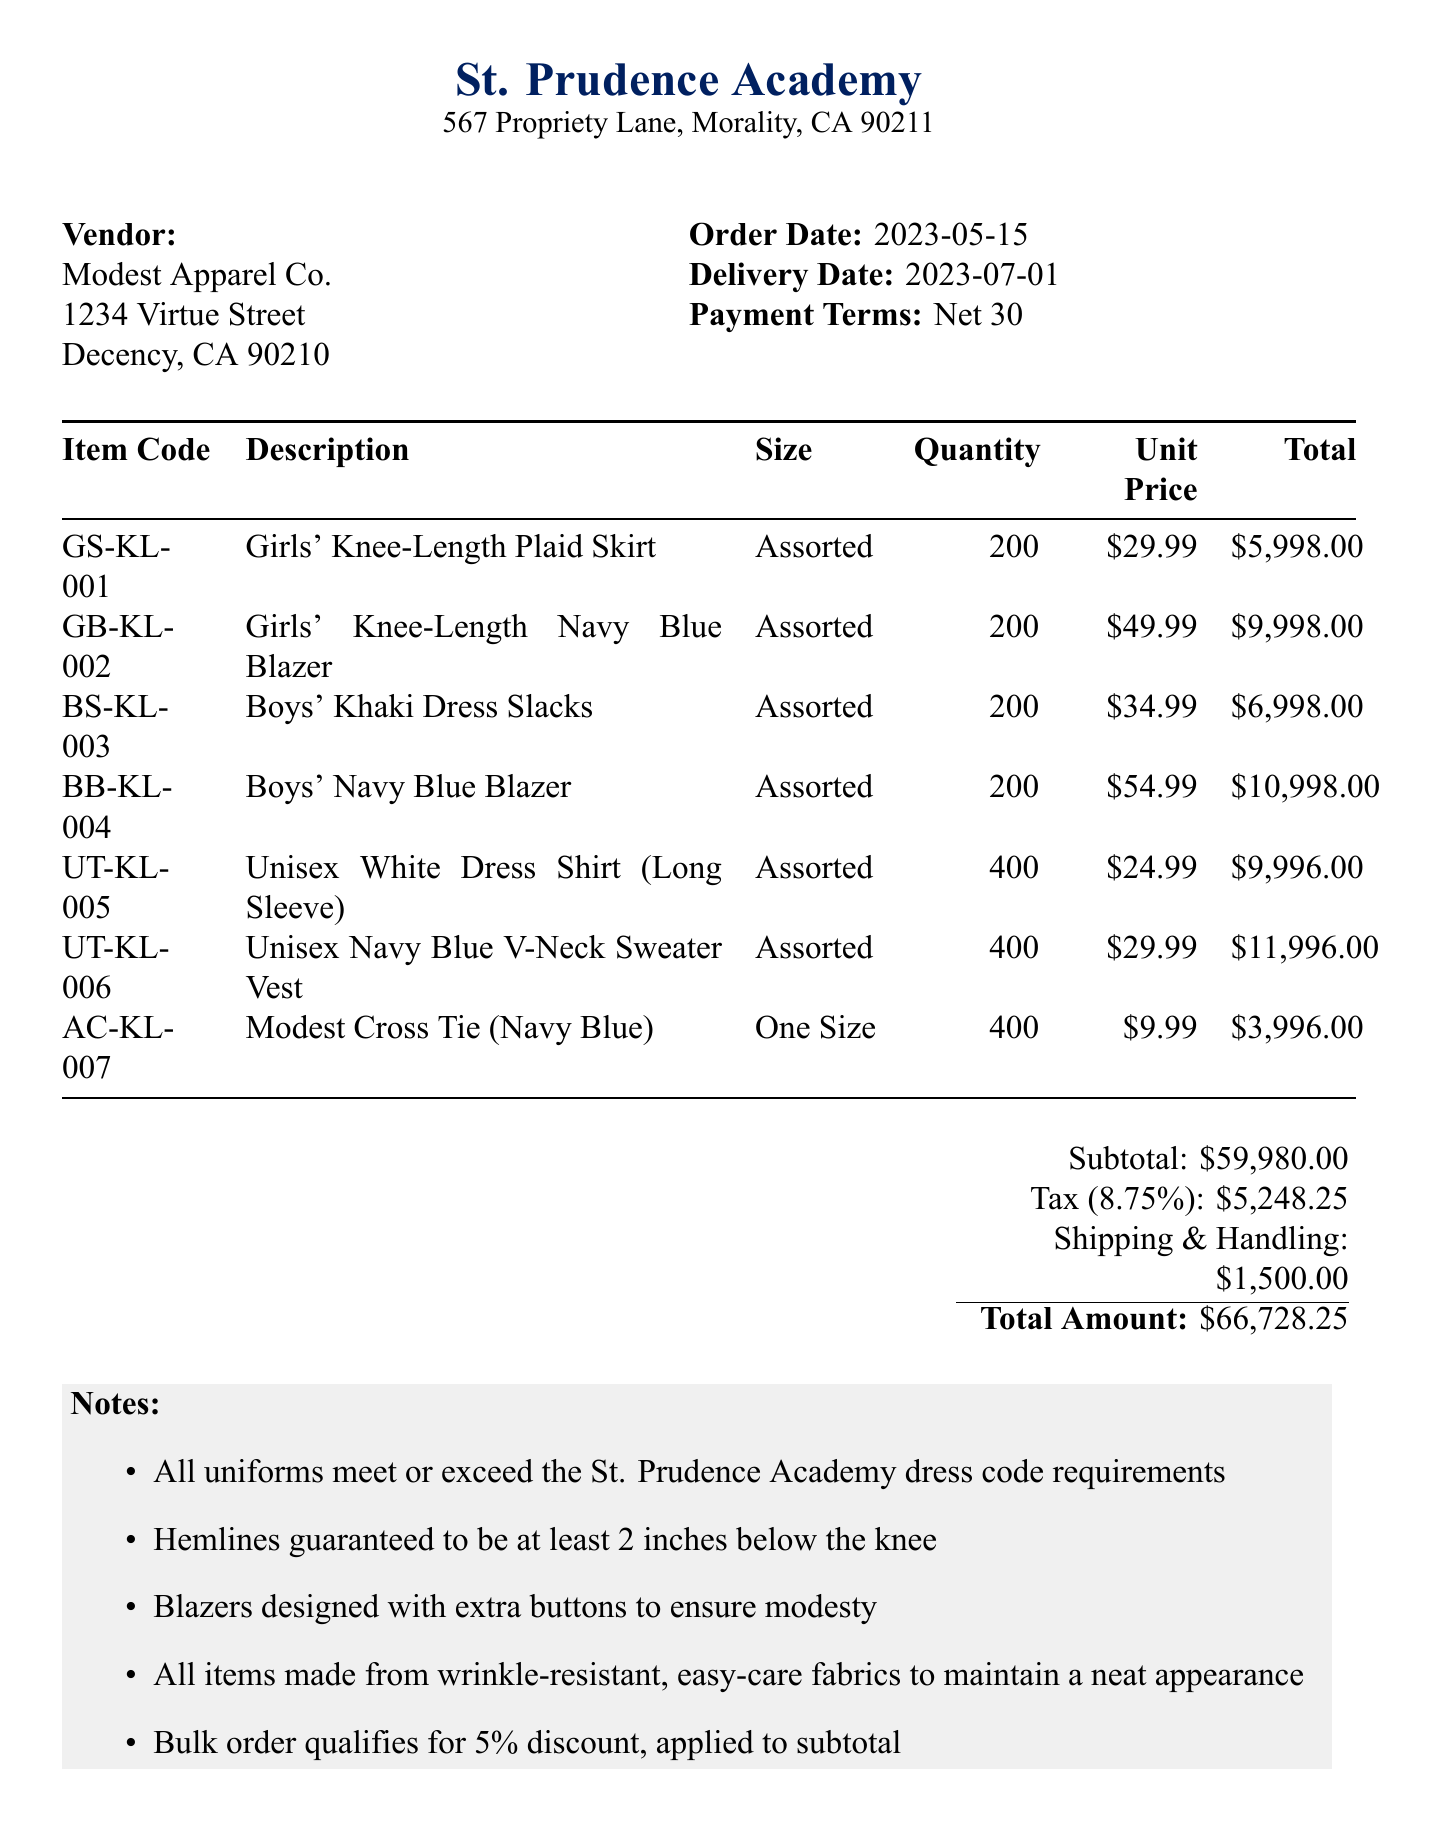What is the vendor's name? The vendor's name is listed at the top of the document, stating "Modest Apparel Co."
Answer: Modest Apparel Co What is the order date? The order date is specified in the document, showing "2023-05-15" under Order Date.
Answer: 2023-05-15 What is the delivery date? The delivery date is found under the same section as the order date, which states "2023-07-01."
Answer: 2023-07-01 What is the total amount of the transaction? The total amount is calculated at the bottom of the document, displaying "Total Amount: $66,728.25."
Answer: $66,728.25 How many units of Girls' Knee-Length Plaid Skirt were purchased? The quantity is indicated in the item table, showing "200" under the respective item.
Answer: 200 Which item has the highest unit price? The item with the highest unit price is identified in the item table as "Boys' Navy Blue Blazer" with a unit price of "$54.99."
Answer: Boys' Navy Blue Blazer What is the subtotal before tax and shipping? The subtotal is presented clearly under the cost summary section as "$59,980.00."
Answer: $59,980.00 What percentage discount is applied to the bulk order? The notes section mentions a "5% discount" applied to the subtotal.
Answer: 5% Do the uniforms meet the dress code requirements? The notes explicitly state that "All uniforms meet or exceed the St. Prudence Academy dress code requirements."
Answer: Yes 